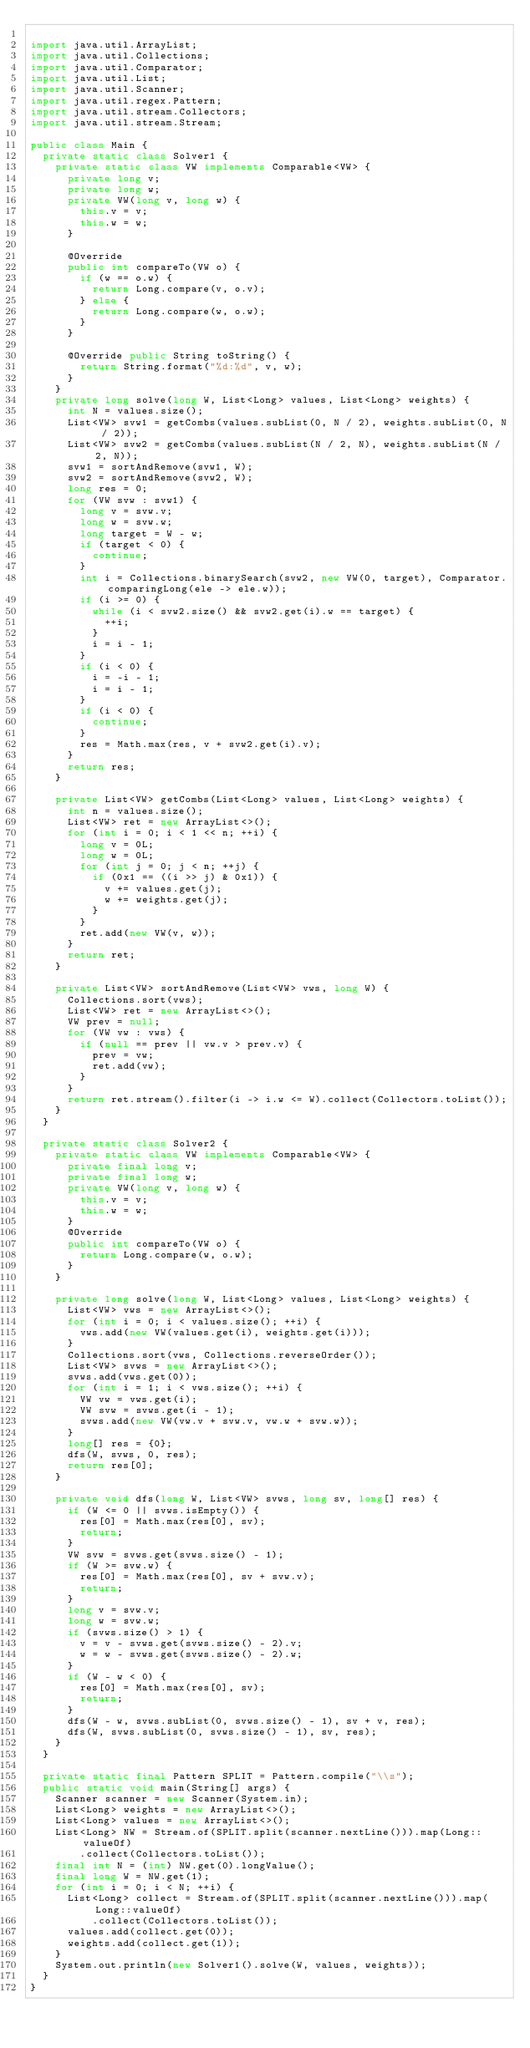<code> <loc_0><loc_0><loc_500><loc_500><_Java_>
import java.util.ArrayList;
import java.util.Collections;
import java.util.Comparator;
import java.util.List;
import java.util.Scanner;
import java.util.regex.Pattern;
import java.util.stream.Collectors;
import java.util.stream.Stream;

public class Main {
  private static class Solver1 {
    private static class VW implements Comparable<VW> {
      private long v;
      private long w;
      private VW(long v, long w) {
        this.v = v;
        this.w = w;
      }

      @Override
      public int compareTo(VW o) {
        if (w == o.w) {
          return Long.compare(v, o.v);
        } else {
          return Long.compare(w, o.w);
        }
      }

      @Override public String toString() {
        return String.format("%d:%d", v, w);
      }
    }
    private long solve(long W, List<Long> values, List<Long> weights) {
      int N = values.size();
      List<VW> svw1 = getCombs(values.subList(0, N / 2), weights.subList(0, N / 2));
      List<VW> svw2 = getCombs(values.subList(N / 2, N), weights.subList(N / 2, N));
      svw1 = sortAndRemove(svw1, W);
      svw2 = sortAndRemove(svw2, W);
      long res = 0;
      for (VW svw : svw1) {
        long v = svw.v;
        long w = svw.w;
        long target = W - w;
        if (target < 0) {
          continue;
        }
        int i = Collections.binarySearch(svw2, new VW(0, target), Comparator.comparingLong(ele -> ele.w));
        if (i >= 0) {
          while (i < svw2.size() && svw2.get(i).w == target) {
            ++i;
          }
          i = i - 1;
        }
        if (i < 0) {
          i = -i - 1;
          i = i - 1;
        }
        if (i < 0) {
          continue;
        }
        res = Math.max(res, v + svw2.get(i).v);
      }
      return res;
    }

    private List<VW> getCombs(List<Long> values, List<Long> weights) {
      int n = values.size();
      List<VW> ret = new ArrayList<>();
      for (int i = 0; i < 1 << n; ++i) {
        long v = 0L;
        long w = 0L;
        for (int j = 0; j < n; ++j) {
          if (0x1 == ((i >> j) & 0x1)) {
            v += values.get(j);
            w += weights.get(j);
          }
        }
        ret.add(new VW(v, w));
      }
      return ret;
    }

    private List<VW> sortAndRemove(List<VW> vws, long W) {
      Collections.sort(vws);
      List<VW> ret = new ArrayList<>();
      VW prev = null;
      for (VW vw : vws) {
        if (null == prev || vw.v > prev.v) {
          prev = vw;
          ret.add(vw);
        }
      }
      return ret.stream().filter(i -> i.w <= W).collect(Collectors.toList());
    }
  }

  private static class Solver2 {
    private static class VW implements Comparable<VW> {
      private final long v;
      private final long w;
      private VW(long v, long w) {
        this.v = v;
        this.w = w;
      }
      @Override
      public int compareTo(VW o) {
        return Long.compare(w, o.w);
      }
    }

    private long solve(long W, List<Long> values, List<Long> weights) {
      List<VW> vws = new ArrayList<>();
      for (int i = 0; i < values.size(); ++i) {
        vws.add(new VW(values.get(i), weights.get(i)));
      }
      Collections.sort(vws, Collections.reverseOrder());
      List<VW> svws = new ArrayList<>();
      svws.add(vws.get(0));
      for (int i = 1; i < vws.size(); ++i) {
        VW vw = vws.get(i);
        VW svw = svws.get(i - 1);
        svws.add(new VW(vw.v + svw.v, vw.w + svw.w));
      }
      long[] res = {0};
      dfs(W, svws, 0, res);
      return res[0];
    }

    private void dfs(long W, List<VW> svws, long sv, long[] res) {
      if (W <= 0 || svws.isEmpty()) {
        res[0] = Math.max(res[0], sv);
        return;
      }
      VW svw = svws.get(svws.size() - 1);
      if (W >= svw.w) {
        res[0] = Math.max(res[0], sv + svw.v);
        return;
      }
      long v = svw.v;
      long w = svw.w;
      if (svws.size() > 1) {
        v = v - svws.get(svws.size() - 2).v;
        w = w - svws.get(svws.size() - 2).w;
      }
      if (W - w < 0) {
        res[0] = Math.max(res[0], sv);
        return;
      }
      dfs(W - w, svws.subList(0, svws.size() - 1), sv + v, res);
      dfs(W, svws.subList(0, svws.size() - 1), sv, res);
    }
  }

  private static final Pattern SPLIT = Pattern.compile("\\s");
  public static void main(String[] args) {
    Scanner scanner = new Scanner(System.in);
    List<Long> weights = new ArrayList<>();
    List<Long> values = new ArrayList<>();
    List<Long> NW = Stream.of(SPLIT.split(scanner.nextLine())).map(Long::valueOf)
        .collect(Collectors.toList());
    final int N = (int) NW.get(0).longValue();
    final long W = NW.get(1);
    for (int i = 0; i < N; ++i) {
      List<Long> collect = Stream.of(SPLIT.split(scanner.nextLine())).map(Long::valueOf)
          .collect(Collectors.toList());
      values.add(collect.get(0));
      weights.add(collect.get(1));
    }
    System.out.println(new Solver1().solve(W, values, weights));
  }
}</code> 